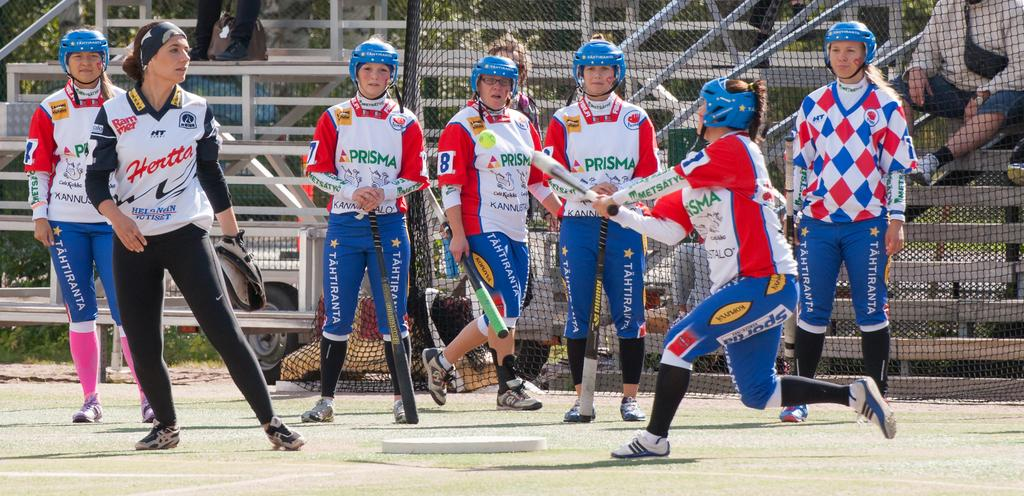Provide a one-sentence caption for the provided image. A female baseball team called Prisma are playing a game on the field. 